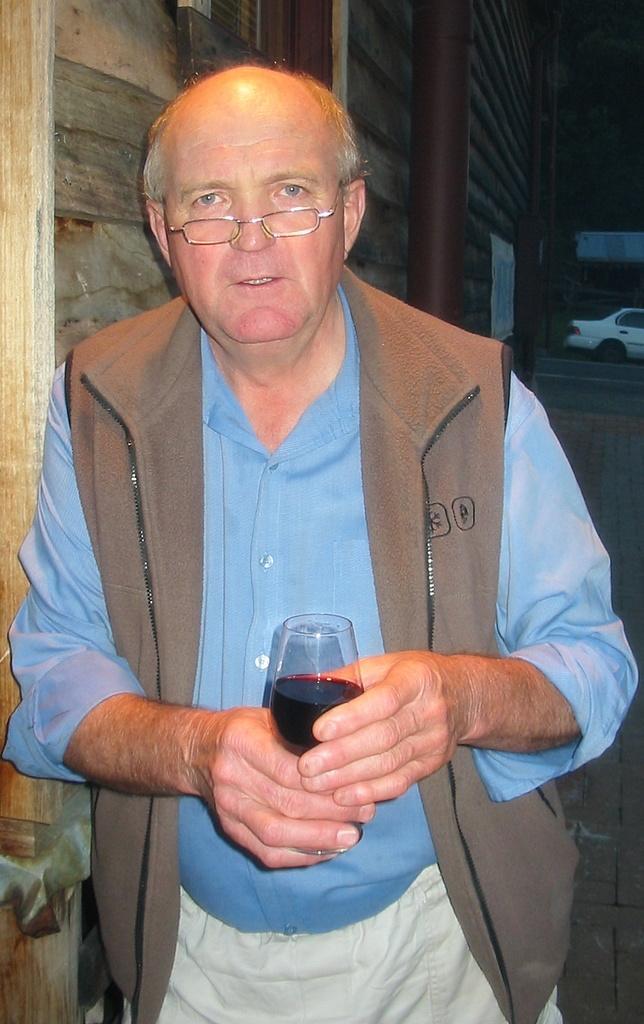Could you give a brief overview of what you see in this image? In this image, there is a man standing and he is holding a glass which contains a black color liquid, In the background there is a white color car, there is a brown color pole. 